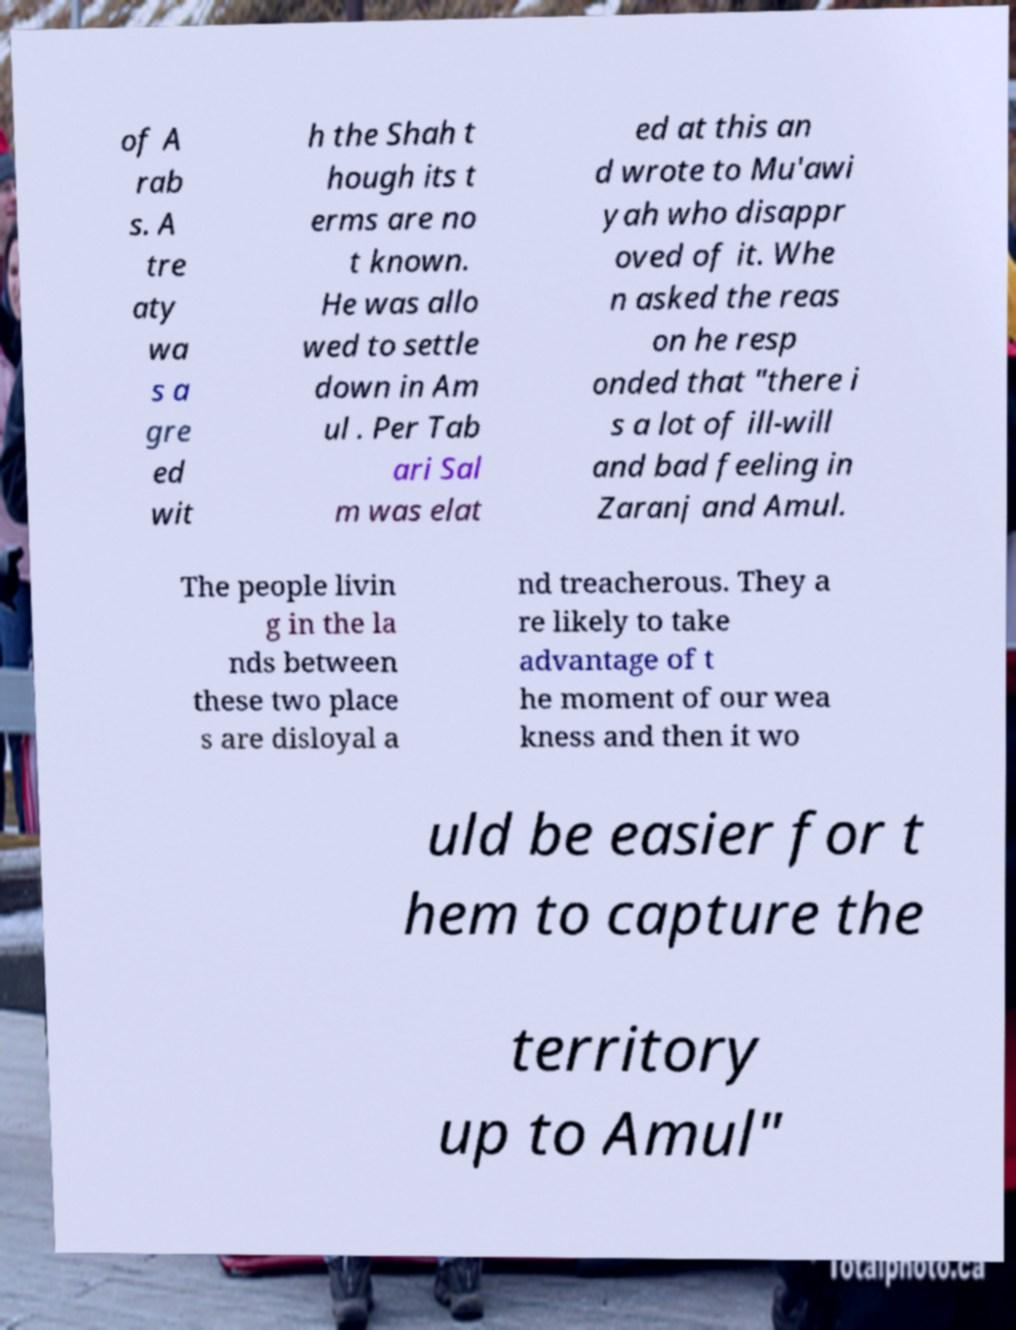Could you extract and type out the text from this image? of A rab s. A tre aty wa s a gre ed wit h the Shah t hough its t erms are no t known. He was allo wed to settle down in Am ul . Per Tab ari Sal m was elat ed at this an d wrote to Mu'awi yah who disappr oved of it. Whe n asked the reas on he resp onded that "there i s a lot of ill-will and bad feeling in Zaranj and Amul. The people livin g in the la nds between these two place s are disloyal a nd treacherous. They a re likely to take advantage of t he moment of our wea kness and then it wo uld be easier for t hem to capture the territory up to Amul" 